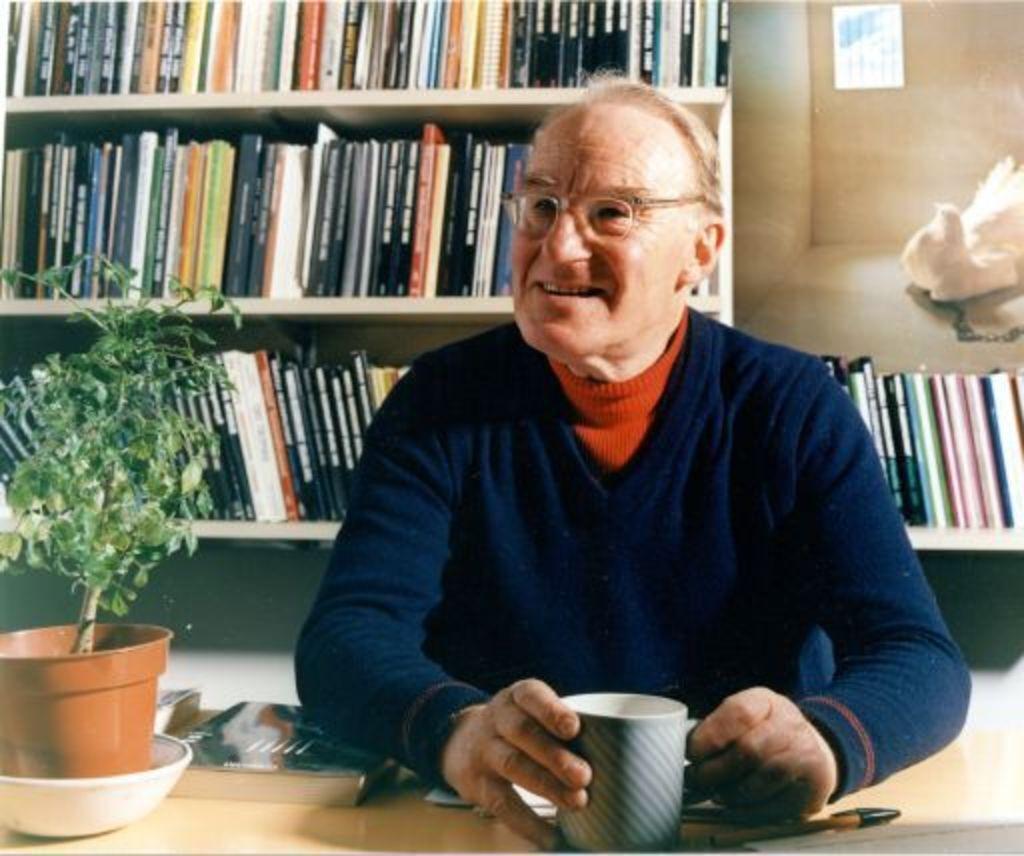Could you give a brief overview of what you see in this image? In the foreground a person is sitting on the chair in front of the table and drinking tea from cup. In the left a house plant is there in the bowl and pen and papers are kept on the table. In the background shelves are visible in which books are kept. The wall of light brown in color visible and a bird visible. This image is taken inside a house. 